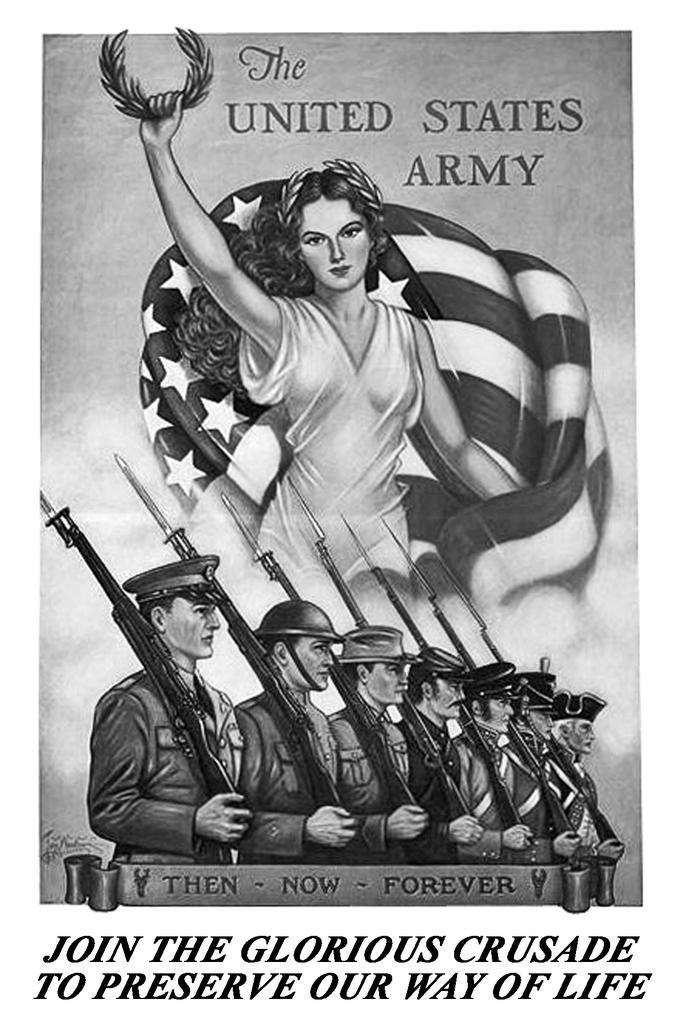How would you summarize this image in a sentence or two? The picture is a poster or a cartoon drawing. At the bottom there is text. In the center of the picture there are soldiers holding guns. At the top there is a woman holding crown behind her there is flag. At the top there is text. 